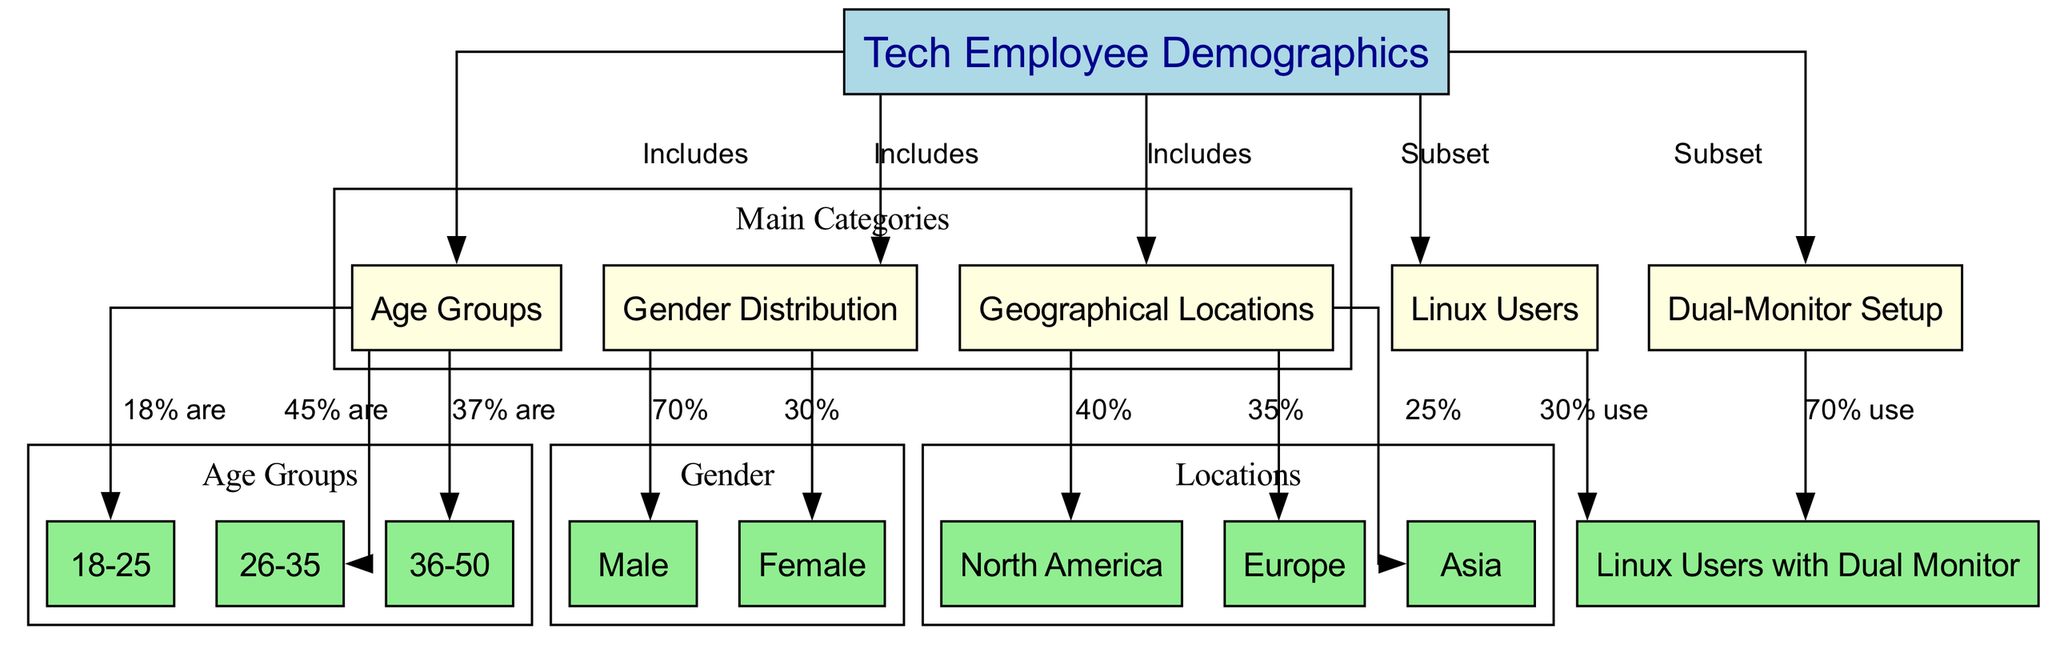What percentage of tech employees are in the 26-35 age group? The diagram indicates that 45% of tech employees are in the 26-35 age group. This information is directly linked from the "Age Groups" node to the specific age group node labeled "26-35."
Answer: 45% What is the gender distribution of tech employees in the corporation? According to the diagram, the gender distribution shows that 70% of tech employees are male and 30% are female. This is summarized from the "Gender Distribution" node linked to the respective gender nodes.
Answer: 70% male, 30% female How many geographical regions are represented in the diagram? There are three geographical regions represented in the diagram: North America, Europe, and Asia. This is counted from the "Geographical Locations" node, which points to the three region nodes underneath it.
Answer: 3 What percentage of tech employees are Linux users? The diagram specifies that 30% of the tech employees are Linux users. This information connects from the "Linux Users" node back to the "Tech Employee Demographics" node.
Answer: 30% What is the percentage of tech employees who use a dual-monitor setup? The diagram indicates that 70% of tech employees use a dual-monitor setup. This is illustrated from the "Dual-Monitor Setup" node leading to the final conclusion about its users.
Answer: 70% How does the demographic of dual-monitor users compare with Linux users? The diagram shows that 70% of dual-monitor users also use Linux, whereas 30% of tech employees are Linux users overall. To find the comparison, we look at the distinct percentages from the "Dual-Monitor Setup" and "Linux Users" nodes and compare 70% of dual-monitor users to the overall 30% Linux users. This indicates that dual-monitor users predominately use Linux.
Answer: 70% vs. 30% Which geographical location has the highest proportion of tech employees? North America has the highest proportion of tech employees at 40%. This is determined by examining the edge from the "Geographical Locations" node to the North America node, which specifies the percentage.
Answer: 40% What age group represents the smallest percentage of tech employees? The age group of 18-25 represents the smallest percentage of tech employees at 18%. This is found by comparing the percentages stated for each age group, specifically identifying the lowest.
Answer: 18% What is the node that includes the gender distribution information? The gender distribution information is included in the node labeled "Gender Distribution." This is identified by tracing back the edges from the "Tech Employee Demographics" node to the corresponding gender node.
Answer: Gender Distribution 